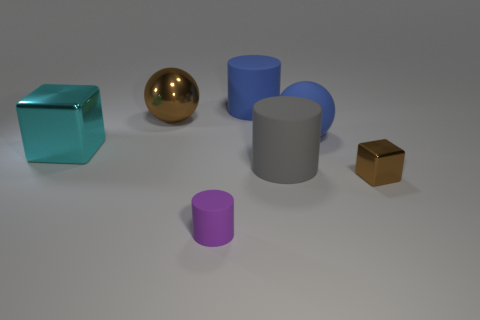Add 2 gray matte cylinders. How many objects exist? 9 Subtract all small cylinders. How many cylinders are left? 2 Add 1 gray things. How many gray things exist? 2 Subtract all blue cylinders. How many cylinders are left? 2 Subtract 0 purple cubes. How many objects are left? 7 Subtract all cubes. How many objects are left? 5 Subtract 1 balls. How many balls are left? 1 Subtract all purple cylinders. Subtract all green spheres. How many cylinders are left? 2 Subtract all gray spheres. How many brown cylinders are left? 0 Subtract all purple rubber cylinders. Subtract all rubber spheres. How many objects are left? 5 